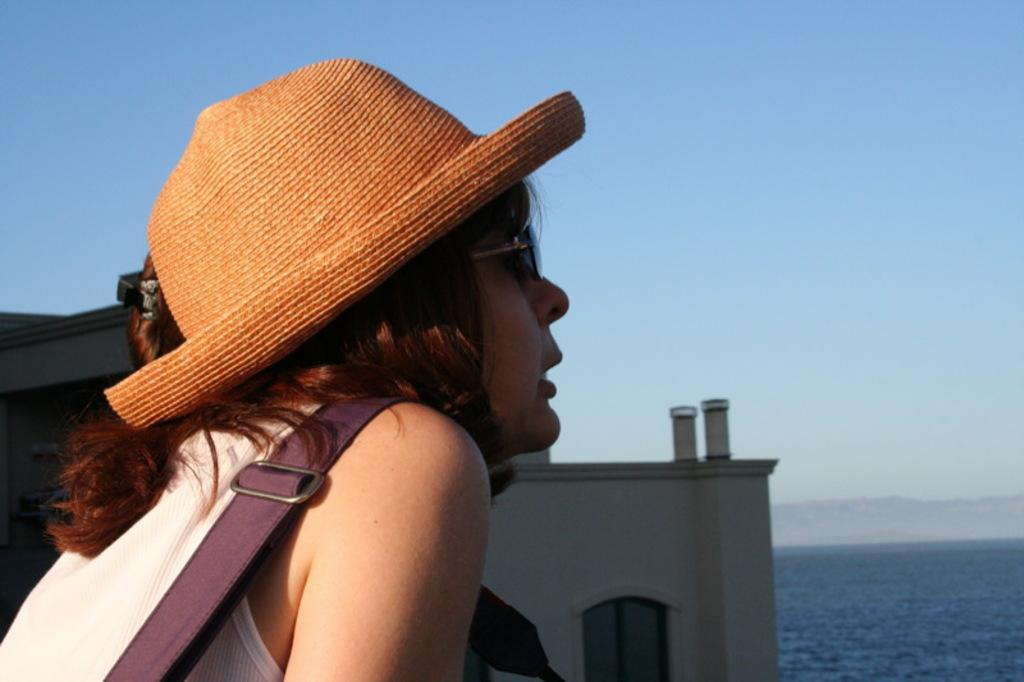What is the person in the image wearing on their head? The person in the image is wearing a hat. What can be seen in the distance behind the person? There is a building, water, a hill, and the sky visible in the background of the image. What type of pencil is the person holding in the image? There is no pencil present in the image; the person is wearing a hat and standing in front of a background with a building, water, a hill, and the sky. 